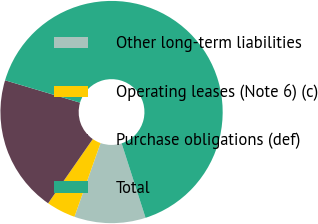Convert chart to OTSL. <chart><loc_0><loc_0><loc_500><loc_500><pie_chart><fcel>Other long-term liabilities<fcel>Operating leases (Note 6) (c)<fcel>Purchase obligations (def)<fcel>Total<nl><fcel>10.37%<fcel>4.25%<fcel>19.94%<fcel>65.44%<nl></chart> 